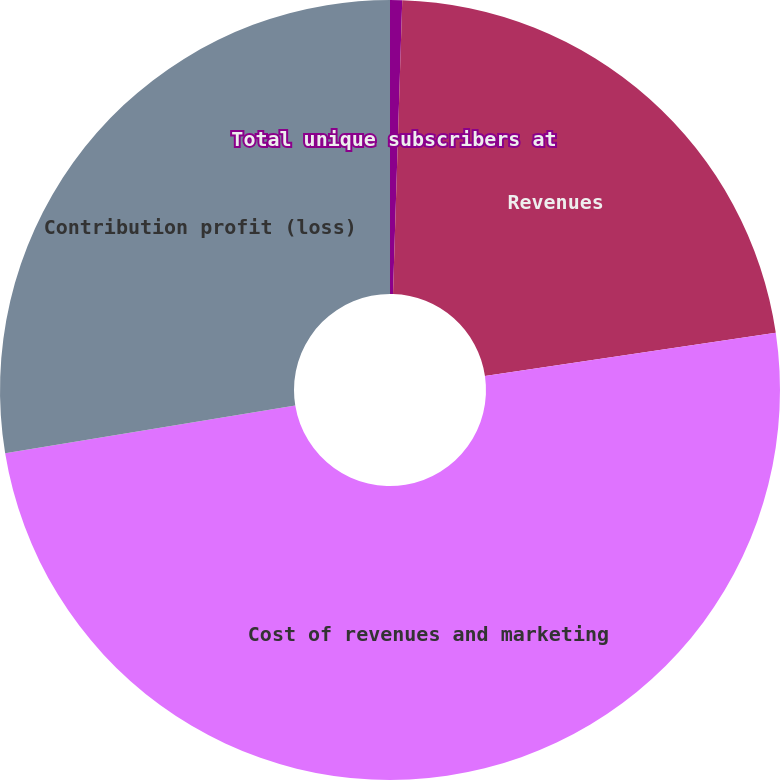<chart> <loc_0><loc_0><loc_500><loc_500><pie_chart><fcel>Total unique subscribers at<fcel>Revenues<fcel>Cost of revenues and marketing<fcel>Contribution profit (loss)<nl><fcel>0.5%<fcel>22.16%<fcel>49.75%<fcel>27.59%<nl></chart> 